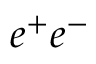<formula> <loc_0><loc_0><loc_500><loc_500>e ^ { + } e ^ { - }</formula> 